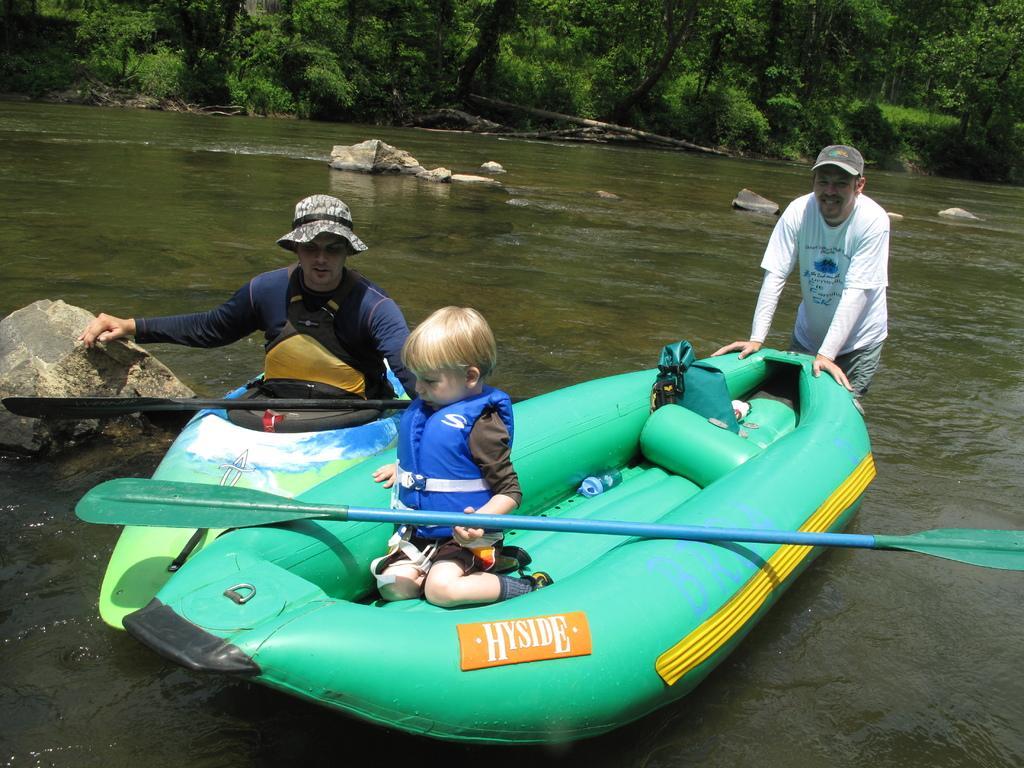Can you describe this image briefly? In this image we can see there is a little boy sitting on the inflatable boat and there is a person pushing this boat. On the other side there is another person on the other boat. In the background there is a river and trees. 